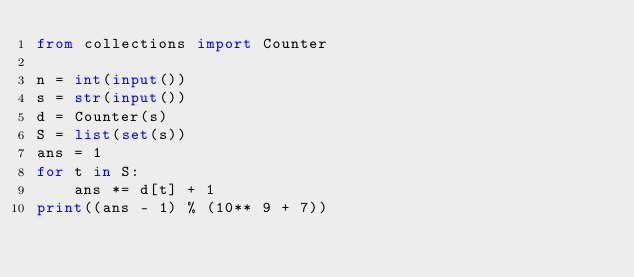Convert code to text. <code><loc_0><loc_0><loc_500><loc_500><_Python_>from collections import Counter

n = int(input())
s = str(input())
d = Counter(s)
S = list(set(s))
ans = 1
for t in S:
    ans *= d[t] + 1
print((ans - 1) % (10** 9 + 7))
</code> 